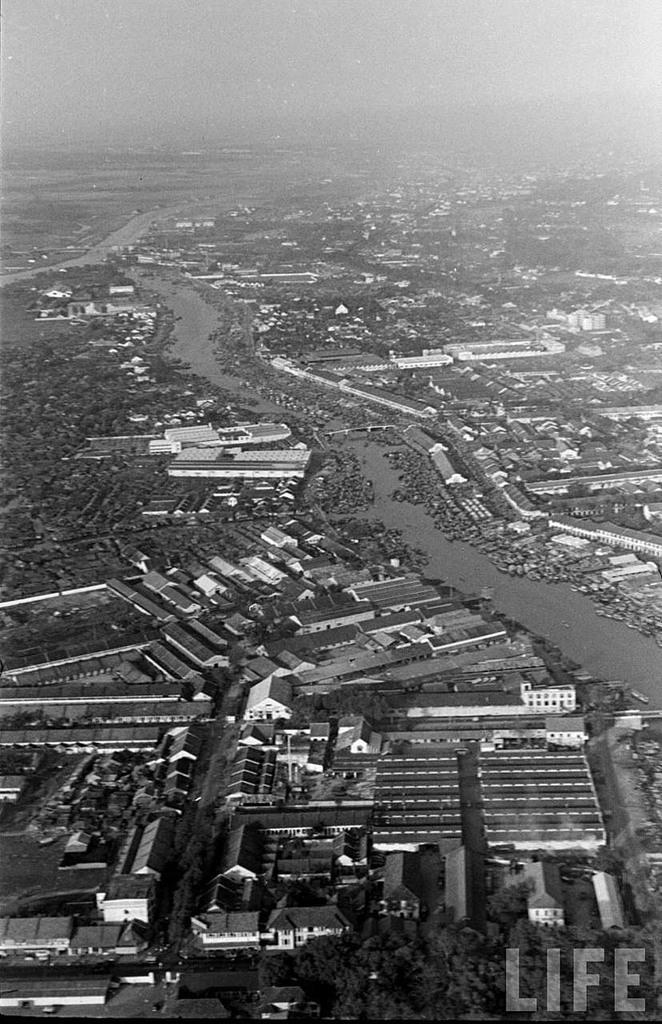What is the color scheme of the image? The image is black and white. What type of structures can be seen in the image? There are buildings in the image. What type of shade is provided by the buildings in the image? There is no mention of shade or any specific details about the buildings in the image, so it cannot be determined from the image. 